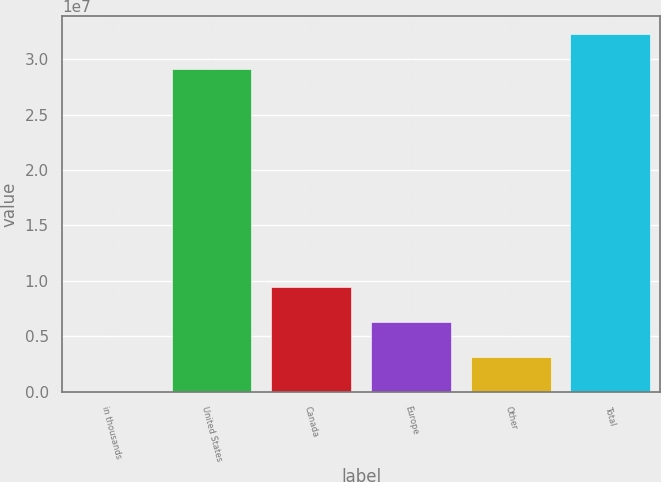Convert chart to OTSL. <chart><loc_0><loc_0><loc_500><loc_500><bar_chart><fcel>in thousands<fcel>United States<fcel>Canada<fcel>Europe<fcel>Other<fcel>Total<nl><fcel>2016<fcel>2.91122e+07<fcel>9.4475e+06<fcel>6.29901e+06<fcel>3.15051e+06<fcel>3.22607e+07<nl></chart> 